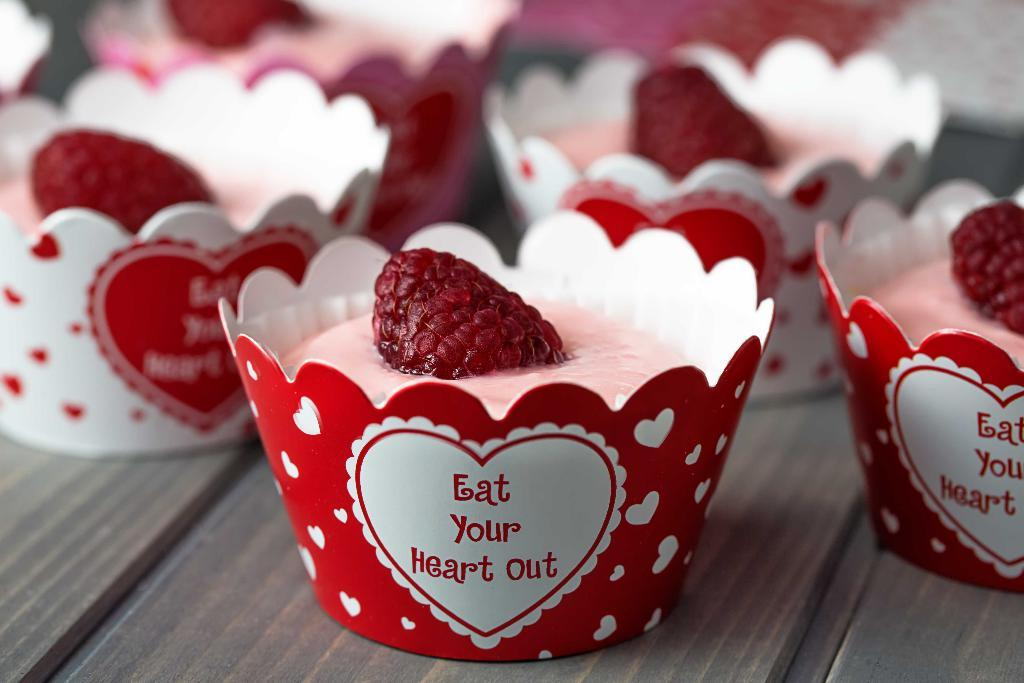What is the main piece of furniture in the image? There is a table in the image. What is placed on the table? There are cups filled with ice cream on the table. Are there any additional toppings or decorations on the cups? Yes, each cup has a strawberry on it. What type of shock can be seen coming from the cups in the image? There is no shock present in the image; it features cups filled with ice cream and strawberries. 